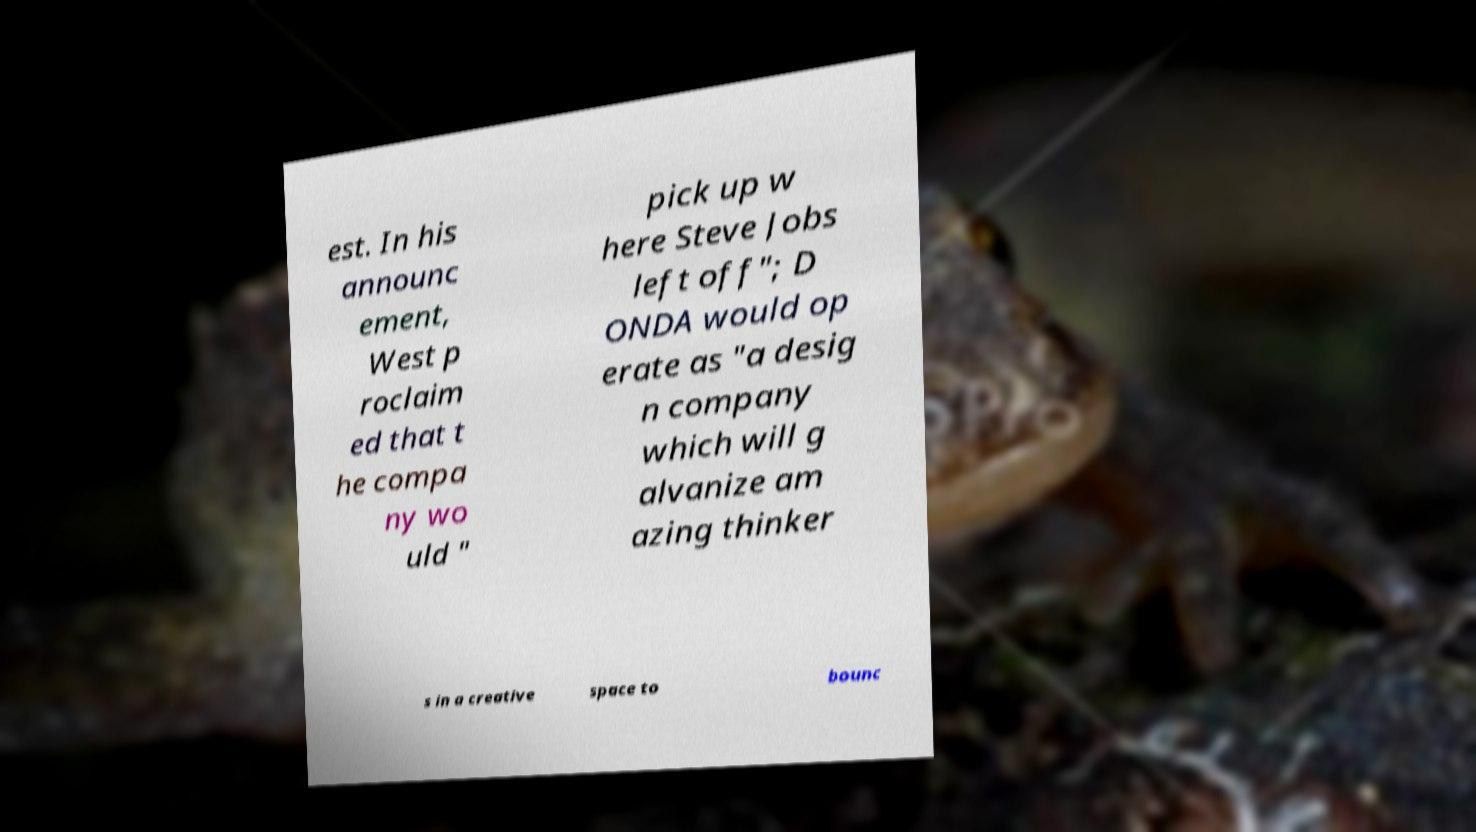There's text embedded in this image that I need extracted. Can you transcribe it verbatim? est. In his announc ement, West p roclaim ed that t he compa ny wo uld " pick up w here Steve Jobs left off"; D ONDA would op erate as "a desig n company which will g alvanize am azing thinker s in a creative space to bounc 